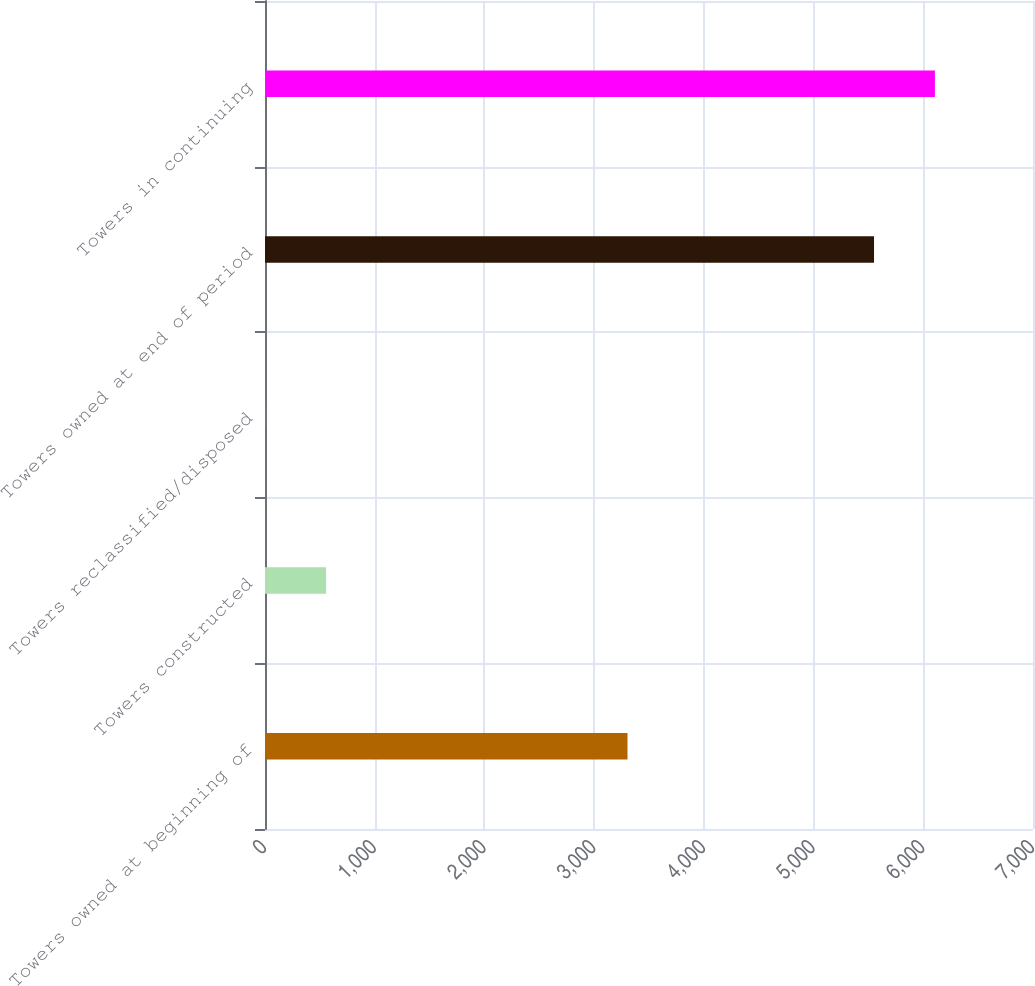Convert chart. <chart><loc_0><loc_0><loc_500><loc_500><bar_chart><fcel>Towers owned at beginning of<fcel>Towers constructed<fcel>Towers reclassified/disposed<fcel>Towers owned at end of period<fcel>Towers in continuing<nl><fcel>3304<fcel>556.9<fcel>2<fcel>5551<fcel>6105.9<nl></chart> 